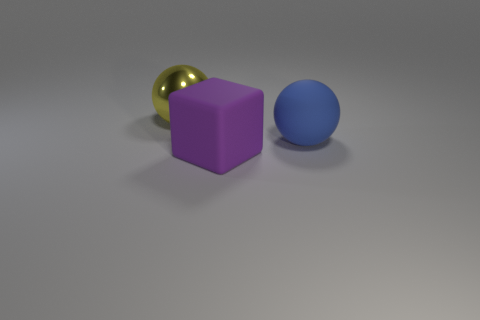Add 3 small red rubber cubes. How many objects exist? 6 Subtract all cubes. How many objects are left? 2 Subtract 0 yellow cylinders. How many objects are left? 3 Subtract all small brown metal spheres. Subtract all large rubber things. How many objects are left? 1 Add 2 blue spheres. How many blue spheres are left? 3 Add 1 large cubes. How many large cubes exist? 2 